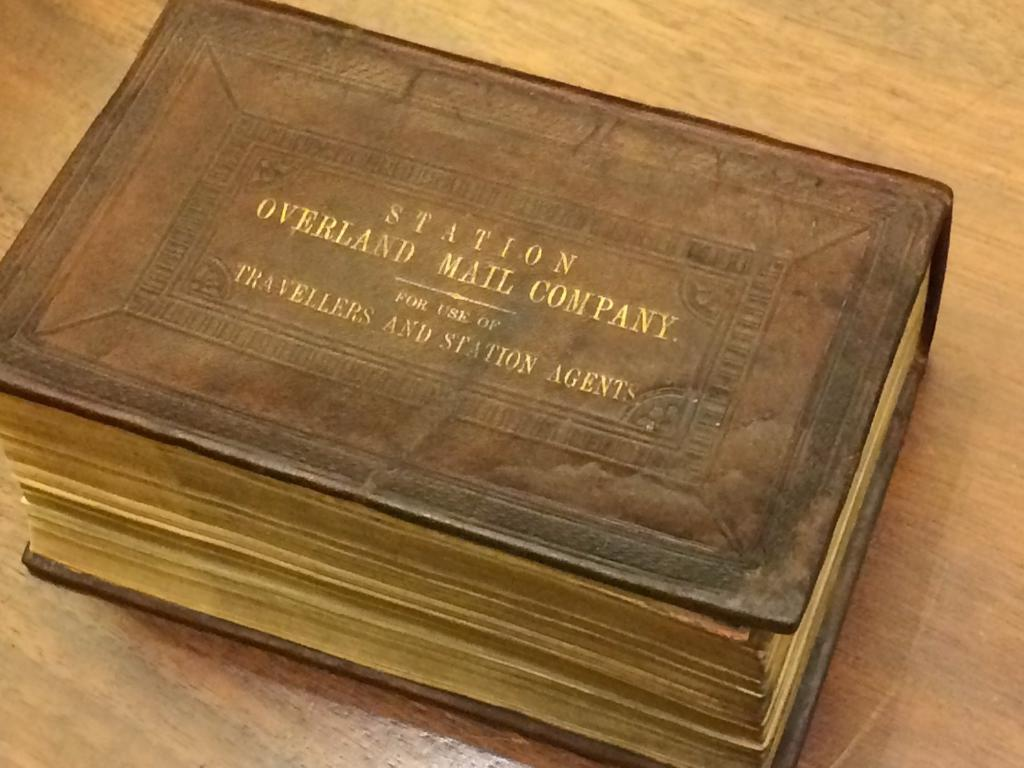<image>
Describe the image concisely. An old leatherbound ledger reads "Station Overland Mail Company, For Use Of Travellers and Station Agents" on the cover. 